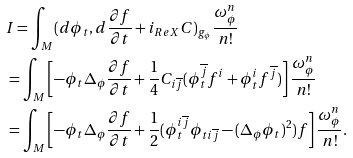<formula> <loc_0><loc_0><loc_500><loc_500>& I = \int _ { M } ( d \phi _ { t } , d \frac { \partial f } { \partial t } + i _ { R e X } C ) _ { g _ { \phi } } \frac { \omega _ { \phi } ^ { n } } { n ! } \\ & = \int _ { M } \left [ - \phi _ { t } \Delta _ { \phi } \frac { \partial f } { \partial t } + \frac { 1 } { 4 } C _ { i \overline { j } } ( \phi _ { t } ^ { \overline { j } } f ^ { i } + \phi _ { t } ^ { i } f ^ { \overline { j } } ) \right ] \frac { \omega _ { \phi } ^ { n } } { n ! } \\ & = \int _ { M } \left [ - \phi _ { t } \Delta _ { \phi } \frac { \partial f } { \partial t } + \frac { 1 } { 2 } ( \phi _ { t } ^ { i \overline { j } } \phi _ { t i \overline { j } } - ( \Delta _ { \phi } \phi _ { t } ) ^ { 2 } ) f \right ] \frac { \omega _ { \phi } ^ { n } } { n ! } .</formula> 